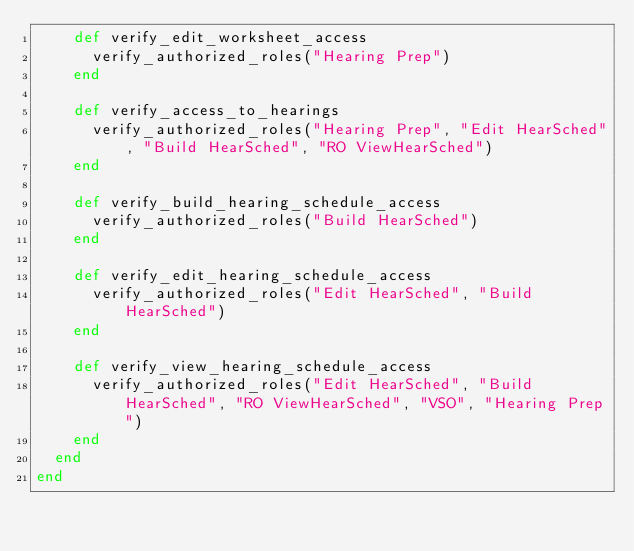Convert code to text. <code><loc_0><loc_0><loc_500><loc_500><_Ruby_>    def verify_edit_worksheet_access
      verify_authorized_roles("Hearing Prep")
    end

    def verify_access_to_hearings
      verify_authorized_roles("Hearing Prep", "Edit HearSched", "Build HearSched", "RO ViewHearSched")
    end

    def verify_build_hearing_schedule_access
      verify_authorized_roles("Build HearSched")
    end

    def verify_edit_hearing_schedule_access
      verify_authorized_roles("Edit HearSched", "Build HearSched")
    end

    def verify_view_hearing_schedule_access
      verify_authorized_roles("Edit HearSched", "Build HearSched", "RO ViewHearSched", "VSO", "Hearing Prep")
    end
  end
end
</code> 